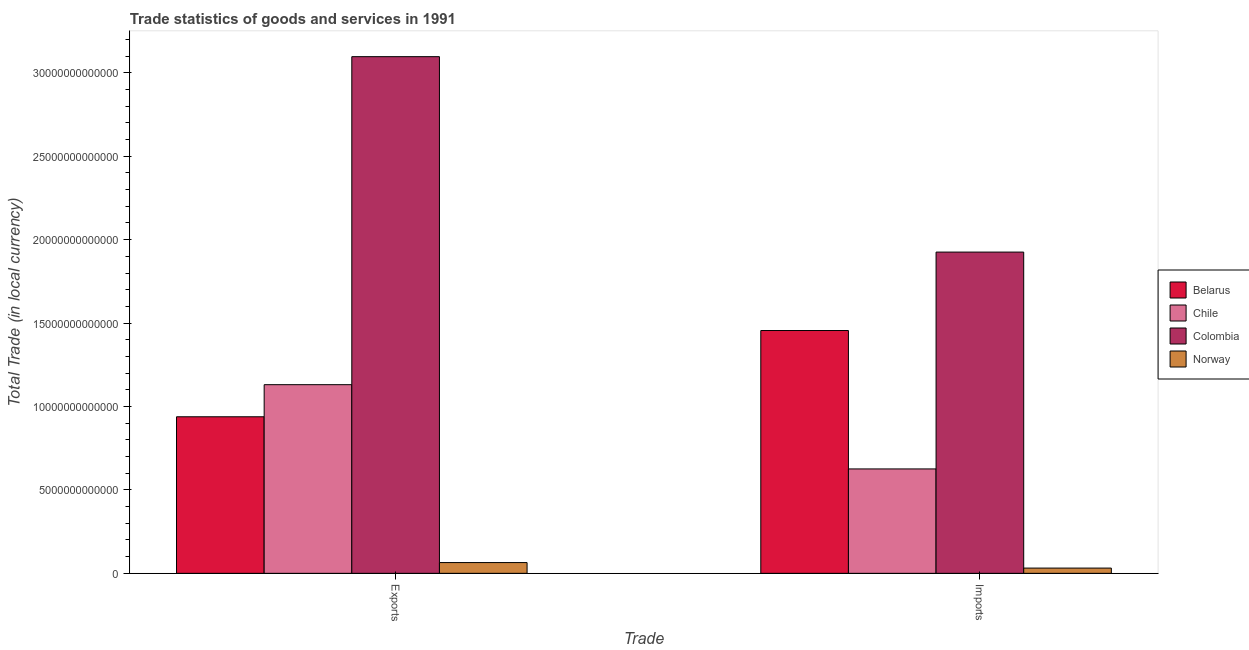How many different coloured bars are there?
Keep it short and to the point. 4. Are the number of bars per tick equal to the number of legend labels?
Your answer should be very brief. Yes. What is the label of the 1st group of bars from the left?
Give a very brief answer. Exports. What is the imports of goods and services in Norway?
Provide a short and direct response. 3.14e+11. Across all countries, what is the maximum imports of goods and services?
Your answer should be very brief. 1.93e+13. Across all countries, what is the minimum export of goods and services?
Your response must be concise. 6.45e+11. In which country was the imports of goods and services minimum?
Provide a succinct answer. Norway. What is the total export of goods and services in the graph?
Provide a succinct answer. 5.23e+13. What is the difference between the export of goods and services in Belarus and that in Norway?
Give a very brief answer. 8.74e+12. What is the difference between the export of goods and services in Colombia and the imports of goods and services in Norway?
Provide a succinct answer. 3.07e+13. What is the average imports of goods and services per country?
Offer a terse response. 1.01e+13. What is the difference between the imports of goods and services and export of goods and services in Norway?
Provide a succinct answer. -3.31e+11. What is the ratio of the export of goods and services in Colombia to that in Chile?
Offer a terse response. 2.74. What does the 4th bar from the left in Imports represents?
Offer a very short reply. Norway. How many bars are there?
Offer a very short reply. 8. Are all the bars in the graph horizontal?
Ensure brevity in your answer.  No. What is the difference between two consecutive major ticks on the Y-axis?
Keep it short and to the point. 5.00e+12. Does the graph contain any zero values?
Offer a very short reply. No. What is the title of the graph?
Your answer should be very brief. Trade statistics of goods and services in 1991. What is the label or title of the X-axis?
Ensure brevity in your answer.  Trade. What is the label or title of the Y-axis?
Your response must be concise. Total Trade (in local currency). What is the Total Trade (in local currency) of Belarus in Exports?
Offer a terse response. 9.38e+12. What is the Total Trade (in local currency) in Chile in Exports?
Your answer should be very brief. 1.13e+13. What is the Total Trade (in local currency) of Colombia in Exports?
Your answer should be compact. 3.10e+13. What is the Total Trade (in local currency) in Norway in Exports?
Make the answer very short. 6.45e+11. What is the Total Trade (in local currency) of Belarus in Imports?
Offer a very short reply. 1.46e+13. What is the Total Trade (in local currency) in Chile in Imports?
Offer a terse response. 6.26e+12. What is the Total Trade (in local currency) in Colombia in Imports?
Ensure brevity in your answer.  1.93e+13. What is the Total Trade (in local currency) in Norway in Imports?
Offer a very short reply. 3.14e+11. Across all Trade, what is the maximum Total Trade (in local currency) of Belarus?
Provide a succinct answer. 1.46e+13. Across all Trade, what is the maximum Total Trade (in local currency) of Chile?
Keep it short and to the point. 1.13e+13. Across all Trade, what is the maximum Total Trade (in local currency) of Colombia?
Your response must be concise. 3.10e+13. Across all Trade, what is the maximum Total Trade (in local currency) in Norway?
Keep it short and to the point. 6.45e+11. Across all Trade, what is the minimum Total Trade (in local currency) of Belarus?
Give a very brief answer. 9.38e+12. Across all Trade, what is the minimum Total Trade (in local currency) in Chile?
Provide a short and direct response. 6.26e+12. Across all Trade, what is the minimum Total Trade (in local currency) in Colombia?
Make the answer very short. 1.93e+13. Across all Trade, what is the minimum Total Trade (in local currency) of Norway?
Your response must be concise. 3.14e+11. What is the total Total Trade (in local currency) of Belarus in the graph?
Keep it short and to the point. 2.39e+13. What is the total Total Trade (in local currency) of Chile in the graph?
Provide a short and direct response. 1.76e+13. What is the total Total Trade (in local currency) in Colombia in the graph?
Offer a very short reply. 5.02e+13. What is the total Total Trade (in local currency) in Norway in the graph?
Provide a succinct answer. 9.59e+11. What is the difference between the Total Trade (in local currency) of Belarus in Exports and that in Imports?
Provide a succinct answer. -5.17e+12. What is the difference between the Total Trade (in local currency) of Chile in Exports and that in Imports?
Keep it short and to the point. 5.05e+12. What is the difference between the Total Trade (in local currency) in Colombia in Exports and that in Imports?
Provide a short and direct response. 1.17e+13. What is the difference between the Total Trade (in local currency) in Norway in Exports and that in Imports?
Provide a succinct answer. 3.31e+11. What is the difference between the Total Trade (in local currency) in Belarus in Exports and the Total Trade (in local currency) in Chile in Imports?
Provide a short and direct response. 3.13e+12. What is the difference between the Total Trade (in local currency) of Belarus in Exports and the Total Trade (in local currency) of Colombia in Imports?
Provide a short and direct response. -9.87e+12. What is the difference between the Total Trade (in local currency) of Belarus in Exports and the Total Trade (in local currency) of Norway in Imports?
Provide a short and direct response. 9.07e+12. What is the difference between the Total Trade (in local currency) in Chile in Exports and the Total Trade (in local currency) in Colombia in Imports?
Your response must be concise. -7.95e+12. What is the difference between the Total Trade (in local currency) in Chile in Exports and the Total Trade (in local currency) in Norway in Imports?
Offer a terse response. 1.10e+13. What is the difference between the Total Trade (in local currency) in Colombia in Exports and the Total Trade (in local currency) in Norway in Imports?
Make the answer very short. 3.07e+13. What is the average Total Trade (in local currency) of Belarus per Trade?
Your answer should be very brief. 1.20e+13. What is the average Total Trade (in local currency) in Chile per Trade?
Your answer should be compact. 8.78e+12. What is the average Total Trade (in local currency) of Colombia per Trade?
Provide a short and direct response. 2.51e+13. What is the average Total Trade (in local currency) in Norway per Trade?
Provide a short and direct response. 4.80e+11. What is the difference between the Total Trade (in local currency) of Belarus and Total Trade (in local currency) of Chile in Exports?
Give a very brief answer. -1.92e+12. What is the difference between the Total Trade (in local currency) of Belarus and Total Trade (in local currency) of Colombia in Exports?
Provide a short and direct response. -2.16e+13. What is the difference between the Total Trade (in local currency) of Belarus and Total Trade (in local currency) of Norway in Exports?
Your answer should be very brief. 8.74e+12. What is the difference between the Total Trade (in local currency) in Chile and Total Trade (in local currency) in Colombia in Exports?
Give a very brief answer. -1.97e+13. What is the difference between the Total Trade (in local currency) of Chile and Total Trade (in local currency) of Norway in Exports?
Your response must be concise. 1.07e+13. What is the difference between the Total Trade (in local currency) in Colombia and Total Trade (in local currency) in Norway in Exports?
Your answer should be compact. 3.03e+13. What is the difference between the Total Trade (in local currency) in Belarus and Total Trade (in local currency) in Chile in Imports?
Make the answer very short. 8.30e+12. What is the difference between the Total Trade (in local currency) of Belarus and Total Trade (in local currency) of Colombia in Imports?
Your answer should be very brief. -4.70e+12. What is the difference between the Total Trade (in local currency) of Belarus and Total Trade (in local currency) of Norway in Imports?
Your response must be concise. 1.42e+13. What is the difference between the Total Trade (in local currency) of Chile and Total Trade (in local currency) of Colombia in Imports?
Provide a succinct answer. -1.30e+13. What is the difference between the Total Trade (in local currency) in Chile and Total Trade (in local currency) in Norway in Imports?
Ensure brevity in your answer.  5.94e+12. What is the difference between the Total Trade (in local currency) in Colombia and Total Trade (in local currency) in Norway in Imports?
Offer a terse response. 1.89e+13. What is the ratio of the Total Trade (in local currency) in Belarus in Exports to that in Imports?
Your answer should be very brief. 0.64. What is the ratio of the Total Trade (in local currency) in Chile in Exports to that in Imports?
Provide a succinct answer. 1.81. What is the ratio of the Total Trade (in local currency) of Colombia in Exports to that in Imports?
Provide a succinct answer. 1.61. What is the ratio of the Total Trade (in local currency) in Norway in Exports to that in Imports?
Offer a terse response. 2.05. What is the difference between the highest and the second highest Total Trade (in local currency) of Belarus?
Your answer should be compact. 5.17e+12. What is the difference between the highest and the second highest Total Trade (in local currency) in Chile?
Your answer should be compact. 5.05e+12. What is the difference between the highest and the second highest Total Trade (in local currency) in Colombia?
Give a very brief answer. 1.17e+13. What is the difference between the highest and the second highest Total Trade (in local currency) in Norway?
Give a very brief answer. 3.31e+11. What is the difference between the highest and the lowest Total Trade (in local currency) in Belarus?
Your response must be concise. 5.17e+12. What is the difference between the highest and the lowest Total Trade (in local currency) of Chile?
Your answer should be compact. 5.05e+12. What is the difference between the highest and the lowest Total Trade (in local currency) in Colombia?
Offer a very short reply. 1.17e+13. What is the difference between the highest and the lowest Total Trade (in local currency) in Norway?
Provide a short and direct response. 3.31e+11. 